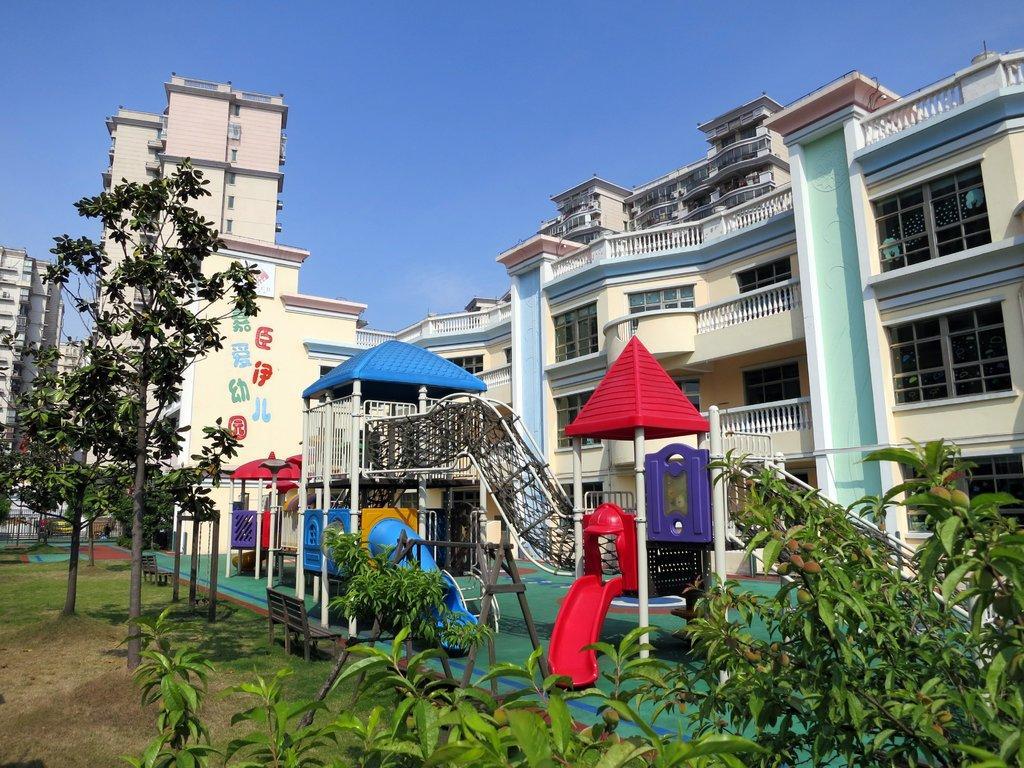Can you describe this image briefly? In this image there are buildings on the right side. In front of the buildings there is a playground in which there are slides and some playing objects. At the top there is the sky. At the bottom there are plants. On the left side there is a building. 